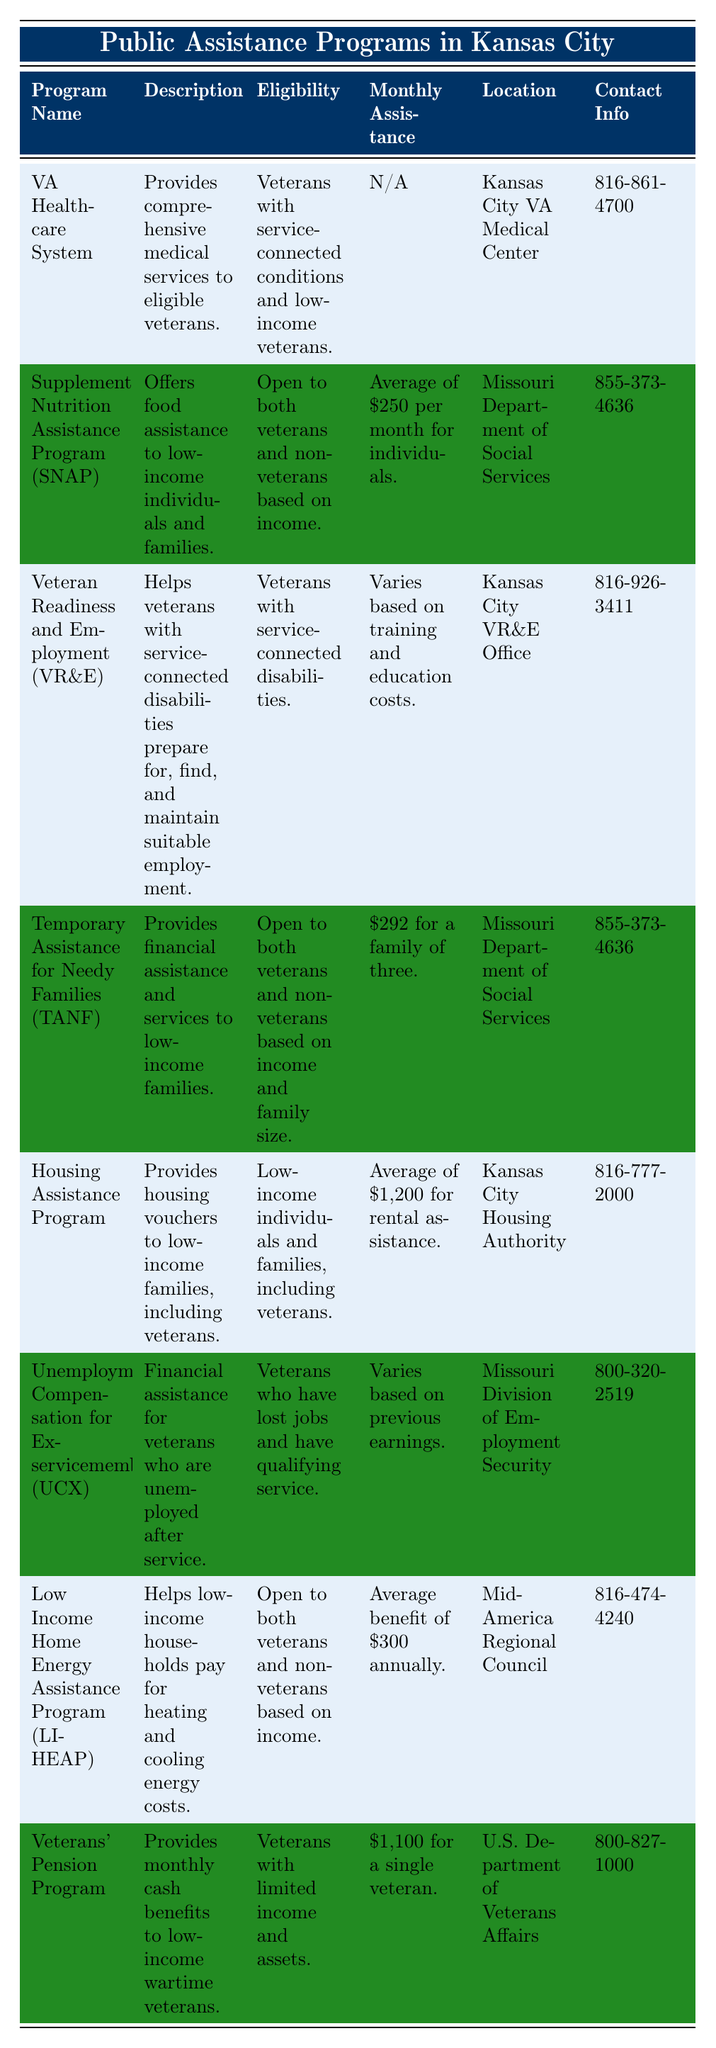What is the eligibility requirement for the VA Healthcare System? The table states that the eligibility for the VA Healthcare System is for veterans with service-connected conditions and low-income veterans.
Answer: Veterans with service-connected conditions and low-income veterans How much monthly assistance does the Veterans' Pension Program provide? According to the table, the Veterans' Pension Program provides $1,100 for a single veteran as monthly assistance.
Answer: $1,100 Is the Low Income Home Energy Assistance Program available to non-veterans? The table indicates that the Low Income Home Energy Assistance Program is open to both veterans and non-veterans based on income, so the answer is yes.
Answer: Yes Which program offers food assistance to low-income individuals? The Supplemental Nutrition Assistance Program (SNAP) offers food assistance as indicated in its description in the table.
Answer: Supplemental Nutrition Assistance Program (SNAP) What is the average monthly assistance for the Housing Assistance Program? The table states the average monthly assistance for the Housing Assistance Program is $1,200 for rental assistance.
Answer: $1,200 How many programs are exclusively for veterans? The programs specifically listed for veterans in the table are VA Healthcare System, Veteran Readiness and Employment (VR&E), Unemployment Compensation for Ex-servicemembers (UCX), and Veterans' Pension Program, totaling four veteran-exclusive programs.
Answer: Four What is the difference in monthly assistance between TANF and the average SNAP assistance? TANF provides $292 for a family of three, and average SNAP assistance is $250 for individuals, making the difference $292 - $250 = $42.
Answer: $42 Are both veterans and non-veterans eligible for the Housing Assistance Program? The table mentions that the Housing Assistance Program is for low-income individuals and families, including veterans, confirming that both groups are eligible.
Answer: Yes Which program provides financial assistance to unemployed veterans? The Unemployment Compensation for Ex-servicemembers (UCX) program provides financial assistance to unemployed veterans.
Answer: Unemployment Compensation for Ex-servicemembers (UCX) What is the location of the Kansas City VA Medical Center? The table specifies that the Kansas City VA Medical Center is the location for the VA Healthcare System program.
Answer: Kansas City VA Medical Center What is the total amount of monthly assistance from the Veterans' Pension Program and the Housing Assistance Program? The Veterans' Pension Program offers $1,100 per month, and the Housing Assistance Program offers $1,200. Adding these gives a total of $1,100 + $1,200 = $2,300.
Answer: $2,300 